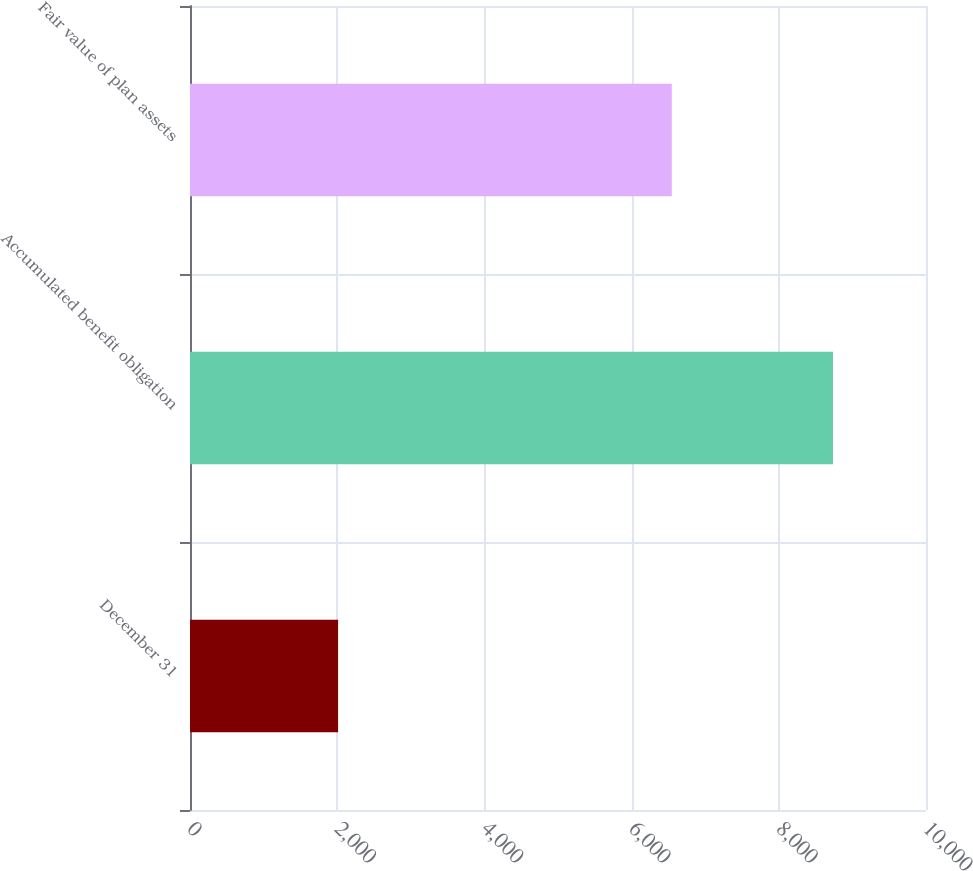Convert chart. <chart><loc_0><loc_0><loc_500><loc_500><bar_chart><fcel>December 31<fcel>Accumulated benefit obligation<fcel>Fair value of plan assets<nl><fcel>2012<fcel>8736<fcel>6546<nl></chart> 